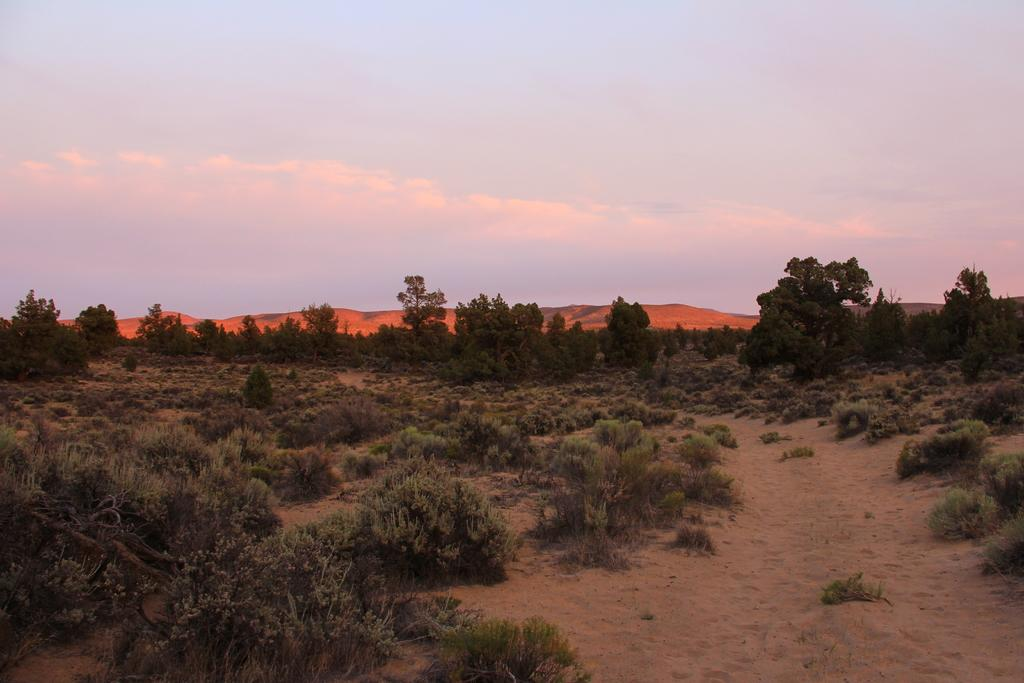What is located in the foreground of the image? There is a land in the foreground of the image. What types of vegetation can be seen on the land? Trees, plants, and bushes are visible on the land. What is the elevated feature in the middle of the image? There is a hill in the middle of the image. What is visible at the top of the image? The sky is visible at the top of the image. What type of patch is being sewn by the daughter in the image? There is no daughter or patch present in the image; it features a land with trees, plants, bushes, a hill, and the sky. 